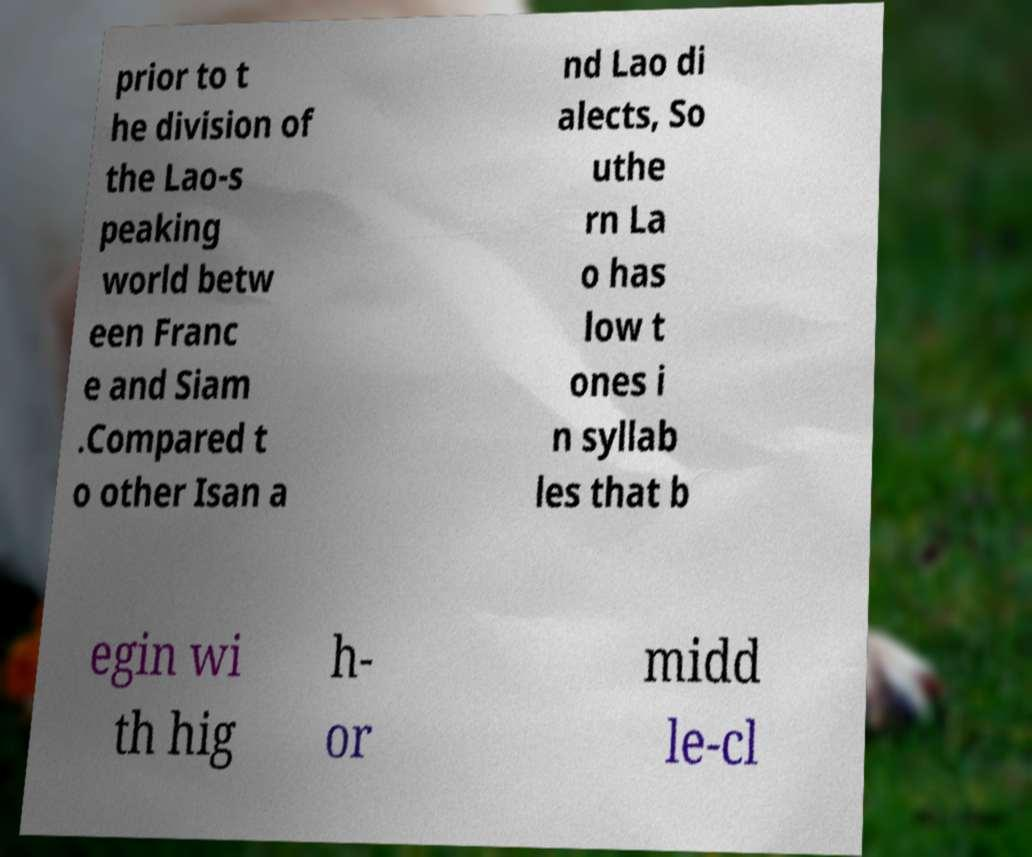I need the written content from this picture converted into text. Can you do that? prior to t he division of the Lao-s peaking world betw een Franc e and Siam .Compared t o other Isan a nd Lao di alects, So uthe rn La o has low t ones i n syllab les that b egin wi th hig h- or midd le-cl 